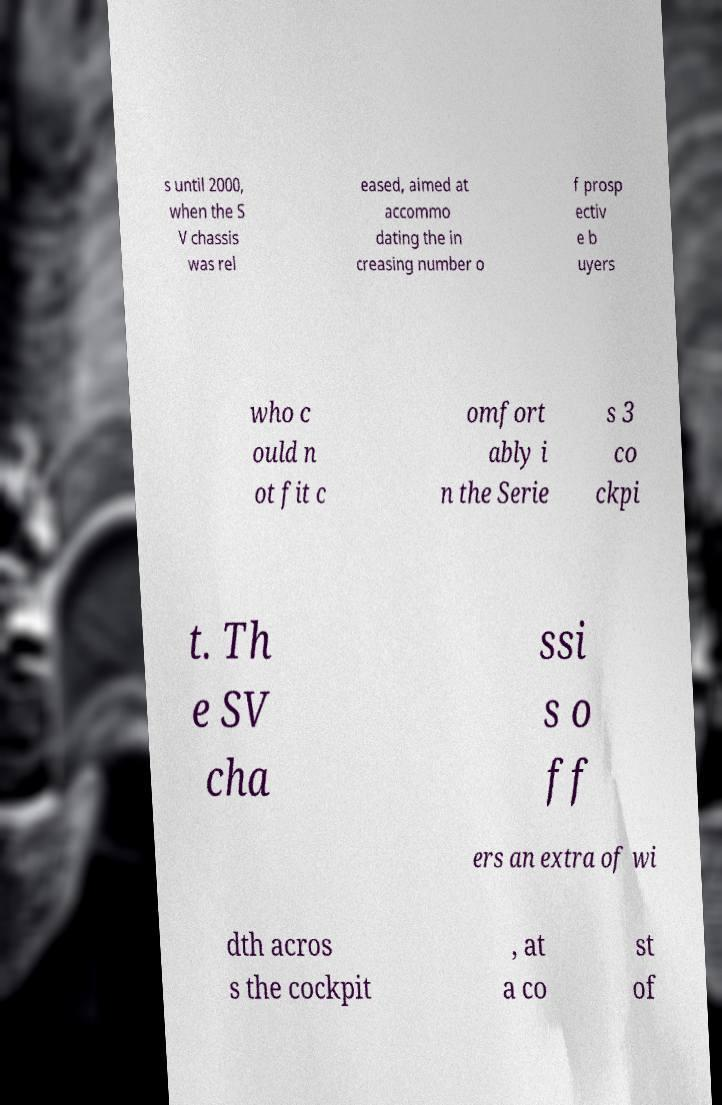Could you assist in decoding the text presented in this image and type it out clearly? s until 2000, when the S V chassis was rel eased, aimed at accommo dating the in creasing number o f prosp ectiv e b uyers who c ould n ot fit c omfort ably i n the Serie s 3 co ckpi t. Th e SV cha ssi s o ff ers an extra of wi dth acros s the cockpit , at a co st of 